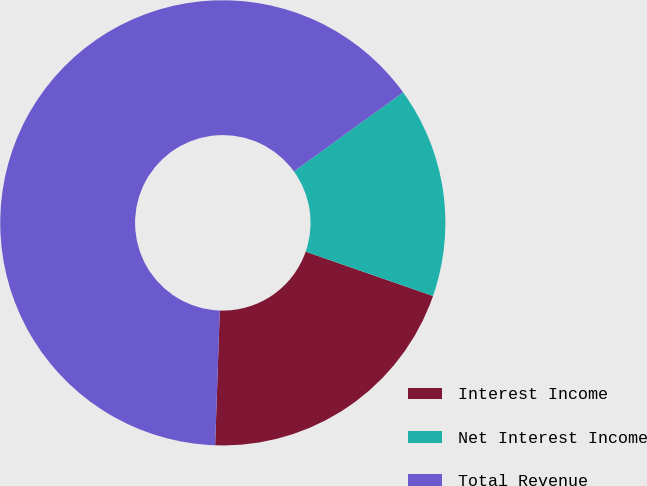Convert chart. <chart><loc_0><loc_0><loc_500><loc_500><pie_chart><fcel>Interest Income<fcel>Net Interest Income<fcel>Total Revenue<nl><fcel>20.22%<fcel>15.3%<fcel>64.48%<nl></chart> 